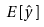Convert formula to latex. <formula><loc_0><loc_0><loc_500><loc_500>E [ \hat { y } ]</formula> 